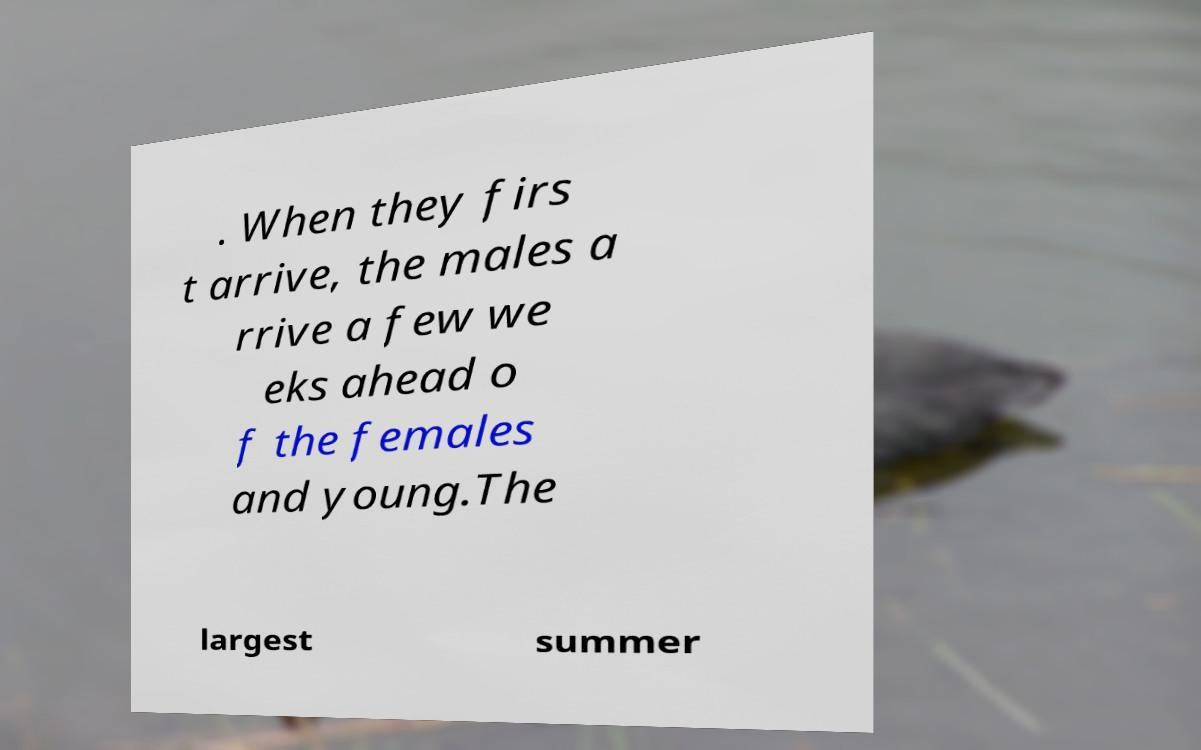Could you extract and type out the text from this image? . When they firs t arrive, the males a rrive a few we eks ahead o f the females and young.The largest summer 